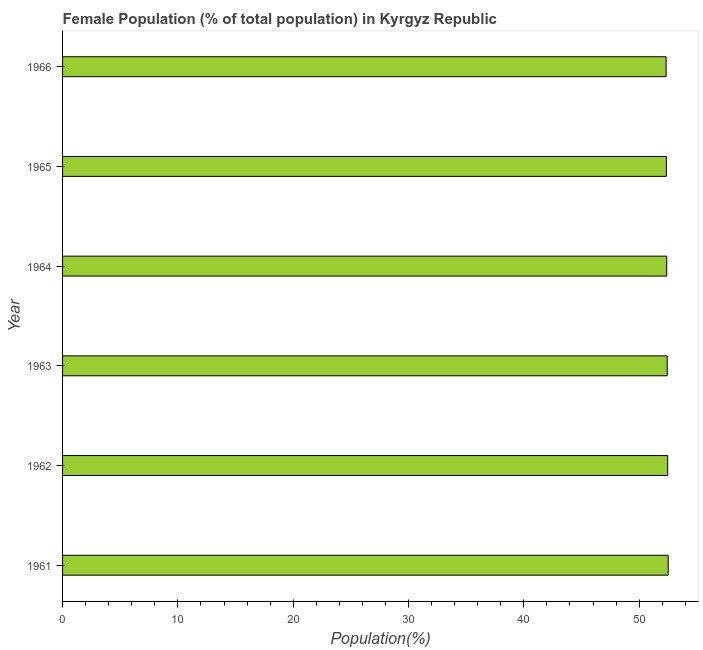Does the graph contain any zero values?
Provide a short and direct response. No. Does the graph contain grids?
Offer a terse response. No. What is the title of the graph?
Your answer should be very brief. Female Population (% of total population) in Kyrgyz Republic. What is the label or title of the X-axis?
Your answer should be compact. Population(%). What is the label or title of the Y-axis?
Offer a terse response. Year. What is the female population in 1961?
Your answer should be compact. 52.52. Across all years, what is the maximum female population?
Your response must be concise. 52.52. Across all years, what is the minimum female population?
Ensure brevity in your answer.  52.34. In which year was the female population maximum?
Give a very brief answer. 1961. In which year was the female population minimum?
Give a very brief answer. 1966. What is the sum of the female population?
Keep it short and to the point. 314.51. What is the difference between the female population in 1963 and 1965?
Make the answer very short. 0.07. What is the average female population per year?
Your response must be concise. 52.42. What is the median female population?
Keep it short and to the point. 52.41. In how many years, is the female population greater than 4 %?
Make the answer very short. 6. Do a majority of the years between 1966 and 1961 (inclusive) have female population greater than 18 %?
Your answer should be compact. Yes. Is the difference between the female population in 1962 and 1966 greater than the difference between any two years?
Your response must be concise. No. What is the difference between the highest and the second highest female population?
Ensure brevity in your answer.  0.04. What is the difference between the highest and the lowest female population?
Provide a short and direct response. 0.18. How many bars are there?
Provide a succinct answer. 6. How many years are there in the graph?
Your response must be concise. 6. What is the Population(%) in 1961?
Your answer should be very brief. 52.52. What is the Population(%) in 1962?
Your answer should be very brief. 52.47. What is the Population(%) in 1963?
Ensure brevity in your answer.  52.43. What is the Population(%) of 1964?
Offer a very short reply. 52.39. What is the Population(%) of 1965?
Your answer should be very brief. 52.36. What is the Population(%) of 1966?
Your response must be concise. 52.34. What is the difference between the Population(%) in 1961 and 1962?
Your answer should be very brief. 0.05. What is the difference between the Population(%) in 1961 and 1963?
Your response must be concise. 0.09. What is the difference between the Population(%) in 1961 and 1964?
Ensure brevity in your answer.  0.13. What is the difference between the Population(%) in 1961 and 1965?
Offer a very short reply. 0.16. What is the difference between the Population(%) in 1961 and 1966?
Provide a short and direct response. 0.18. What is the difference between the Population(%) in 1962 and 1963?
Keep it short and to the point. 0.04. What is the difference between the Population(%) in 1962 and 1964?
Make the answer very short. 0.08. What is the difference between the Population(%) in 1962 and 1965?
Your answer should be compact. 0.11. What is the difference between the Population(%) in 1962 and 1966?
Ensure brevity in your answer.  0.14. What is the difference between the Population(%) in 1963 and 1964?
Your response must be concise. 0.04. What is the difference between the Population(%) in 1963 and 1965?
Your answer should be compact. 0.07. What is the difference between the Population(%) in 1963 and 1966?
Ensure brevity in your answer.  0.09. What is the difference between the Population(%) in 1964 and 1965?
Your answer should be very brief. 0.03. What is the difference between the Population(%) in 1964 and 1966?
Provide a succinct answer. 0.05. What is the difference between the Population(%) in 1965 and 1966?
Ensure brevity in your answer.  0.02. What is the ratio of the Population(%) in 1961 to that in 1962?
Make the answer very short. 1. What is the ratio of the Population(%) in 1961 to that in 1963?
Your response must be concise. 1. What is the ratio of the Population(%) in 1962 to that in 1964?
Keep it short and to the point. 1. What is the ratio of the Population(%) in 1962 to that in 1965?
Make the answer very short. 1. What is the ratio of the Population(%) in 1962 to that in 1966?
Your answer should be compact. 1. What is the ratio of the Population(%) in 1963 to that in 1965?
Offer a terse response. 1. What is the ratio of the Population(%) in 1963 to that in 1966?
Your answer should be compact. 1. What is the ratio of the Population(%) in 1964 to that in 1966?
Your response must be concise. 1. What is the ratio of the Population(%) in 1965 to that in 1966?
Ensure brevity in your answer.  1. 